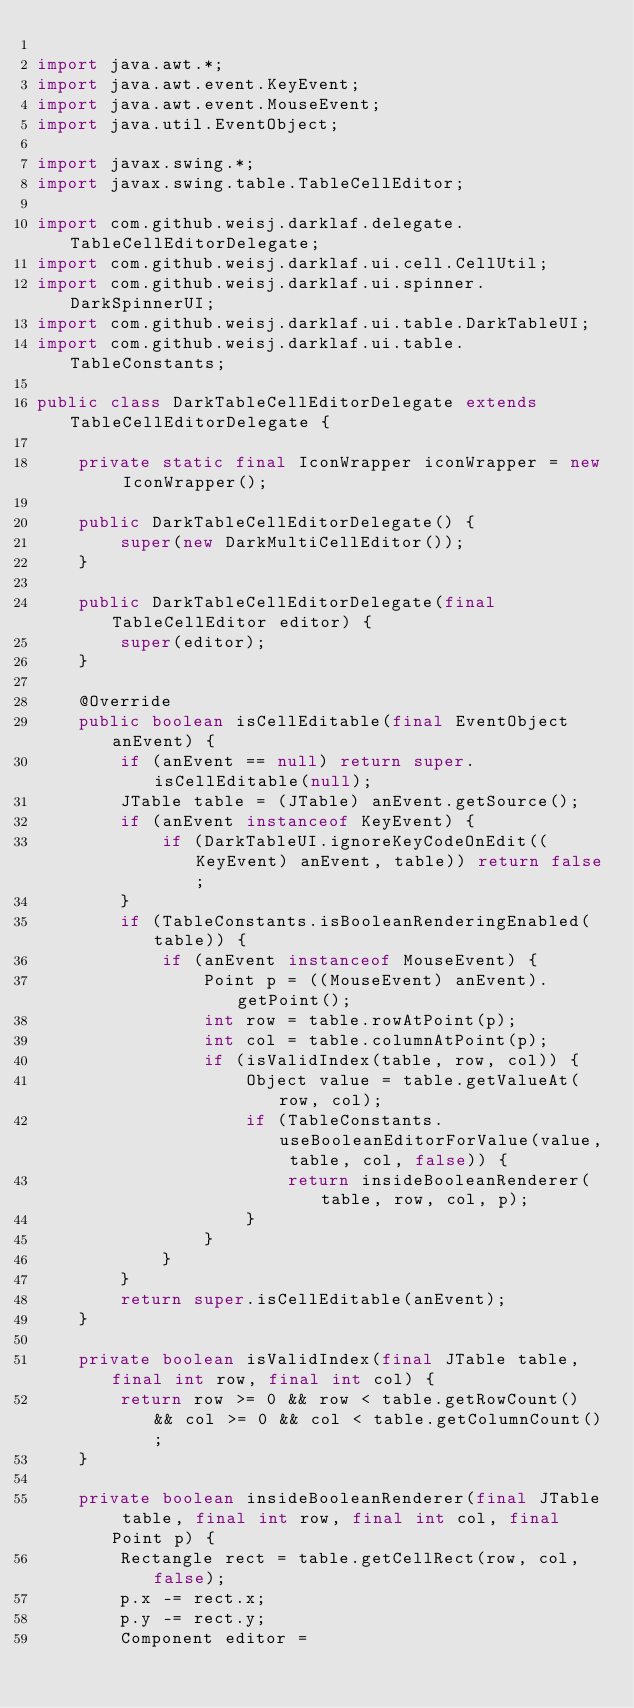<code> <loc_0><loc_0><loc_500><loc_500><_Java_>
import java.awt.*;
import java.awt.event.KeyEvent;
import java.awt.event.MouseEvent;
import java.util.EventObject;

import javax.swing.*;
import javax.swing.table.TableCellEditor;

import com.github.weisj.darklaf.delegate.TableCellEditorDelegate;
import com.github.weisj.darklaf.ui.cell.CellUtil;
import com.github.weisj.darklaf.ui.spinner.DarkSpinnerUI;
import com.github.weisj.darklaf.ui.table.DarkTableUI;
import com.github.weisj.darklaf.ui.table.TableConstants;

public class DarkTableCellEditorDelegate extends TableCellEditorDelegate {

    private static final IconWrapper iconWrapper = new IconWrapper();

    public DarkTableCellEditorDelegate() {
        super(new DarkMultiCellEditor());
    }

    public DarkTableCellEditorDelegate(final TableCellEditor editor) {
        super(editor);
    }

    @Override
    public boolean isCellEditable(final EventObject anEvent) {
        if (anEvent == null) return super.isCellEditable(null);
        JTable table = (JTable) anEvent.getSource();
        if (anEvent instanceof KeyEvent) {
            if (DarkTableUI.ignoreKeyCodeOnEdit((KeyEvent) anEvent, table)) return false;
        }
        if (TableConstants.isBooleanRenderingEnabled(table)) {
            if (anEvent instanceof MouseEvent) {
                Point p = ((MouseEvent) anEvent).getPoint();
                int row = table.rowAtPoint(p);
                int col = table.columnAtPoint(p);
                if (isValidIndex(table, row, col)) {
                    Object value = table.getValueAt(row, col);
                    if (TableConstants.useBooleanEditorForValue(value, table, col, false)) {
                        return insideBooleanRenderer(table, row, col, p);
                    }
                }
            }
        }
        return super.isCellEditable(anEvent);
    }

    private boolean isValidIndex(final JTable table, final int row, final int col) {
        return row >= 0 && row < table.getRowCount() && col >= 0 && col < table.getColumnCount();
    }

    private boolean insideBooleanRenderer(final JTable table, final int row, final int col, final Point p) {
        Rectangle rect = table.getCellRect(row, col, false);
        p.x -= rect.x;
        p.y -= rect.y;
        Component editor =</code> 